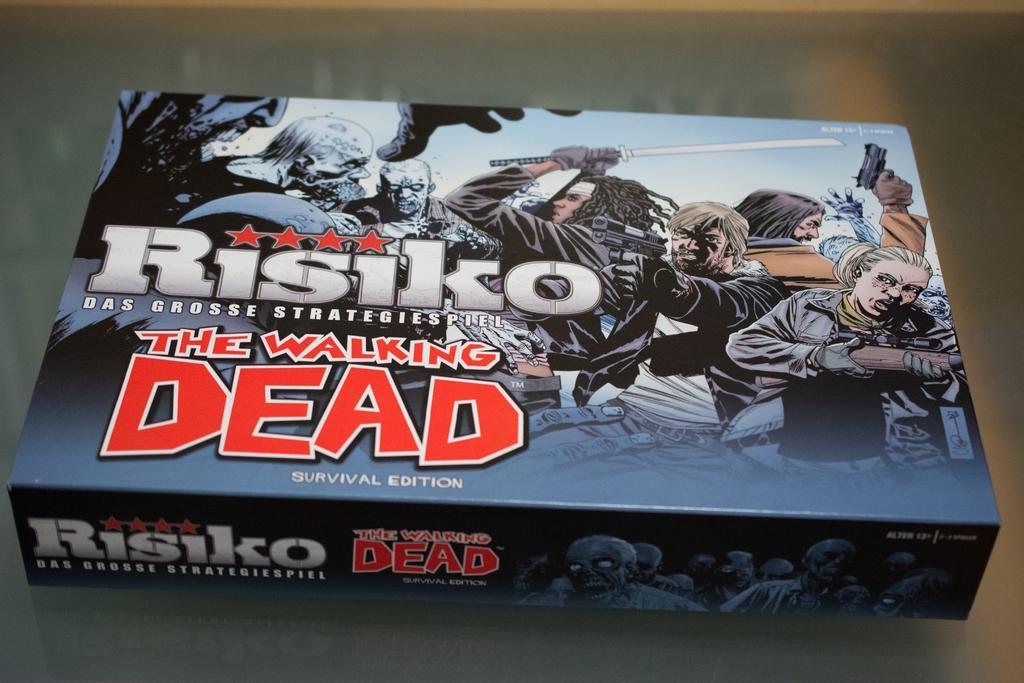Could you give a brief overview of what you see in this image? In this picture there is a box and there are pictures of group of people on the box and there is text. At the bottom it might be table and there is a reflection of box on the table. 